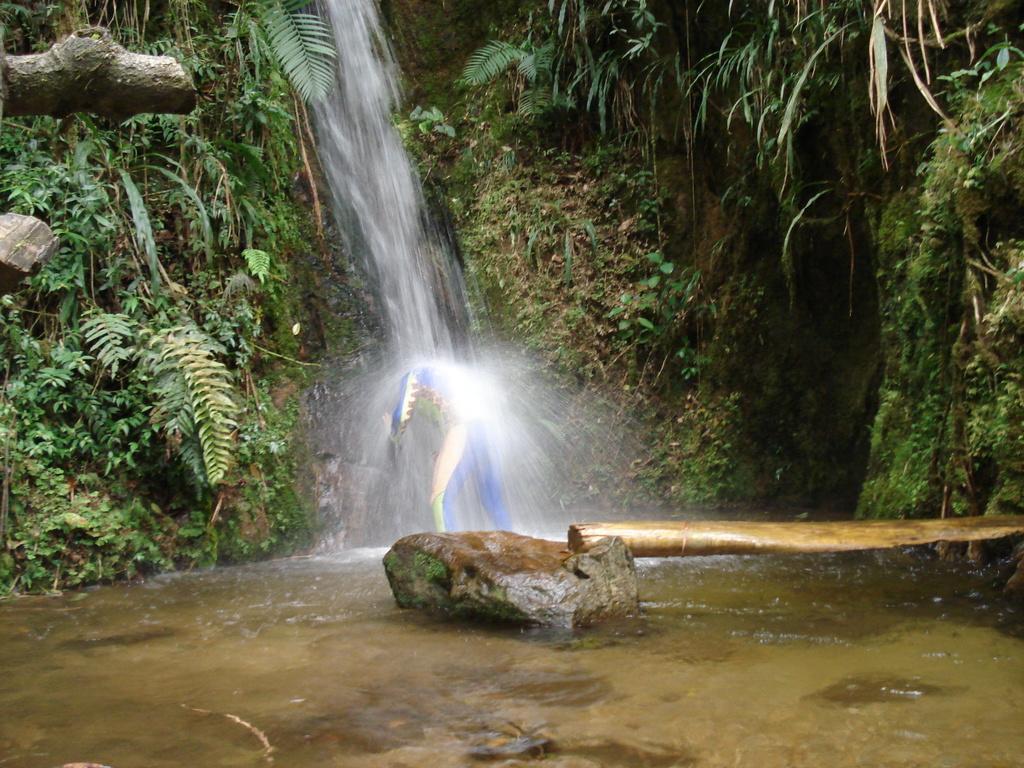In one or two sentences, can you explain what this image depicts? In the image we can see a person wearing clothes, this is a waterfall, wooden stick, water and stones. There are plants and grass. 